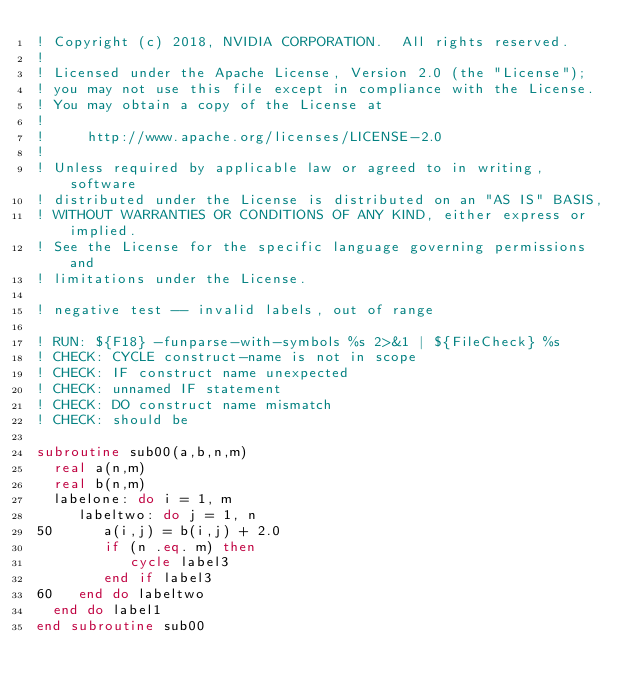<code> <loc_0><loc_0><loc_500><loc_500><_FORTRAN_>! Copyright (c) 2018, NVIDIA CORPORATION.  All rights reserved.
!
! Licensed under the Apache License, Version 2.0 (the "License");
! you may not use this file except in compliance with the License.
! You may obtain a copy of the License at
!
!     http://www.apache.org/licenses/LICENSE-2.0
!
! Unless required by applicable law or agreed to in writing, software
! distributed under the License is distributed on an "AS IS" BASIS,
! WITHOUT WARRANTIES OR CONDITIONS OF ANY KIND, either express or implied.
! See the License for the specific language governing permissions and
! limitations under the License.

! negative test -- invalid labels, out of range

! RUN: ${F18} -funparse-with-symbols %s 2>&1 | ${FileCheck} %s
! CHECK: CYCLE construct-name is not in scope
! CHECK: IF construct name unexpected
! CHECK: unnamed IF statement
! CHECK: DO construct name mismatch
! CHECK: should be

subroutine sub00(a,b,n,m)
  real a(n,m)
  real b(n,m)
  labelone: do i = 1, m
     labeltwo: do j = 1, n
50      a(i,j) = b(i,j) + 2.0
        if (n .eq. m) then
           cycle label3
        end if label3
60   end do labeltwo
  end do label1
end subroutine sub00
</code> 